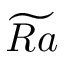Convert formula to latex. <formula><loc_0><loc_0><loc_500><loc_500>\widetilde { R a }</formula> 